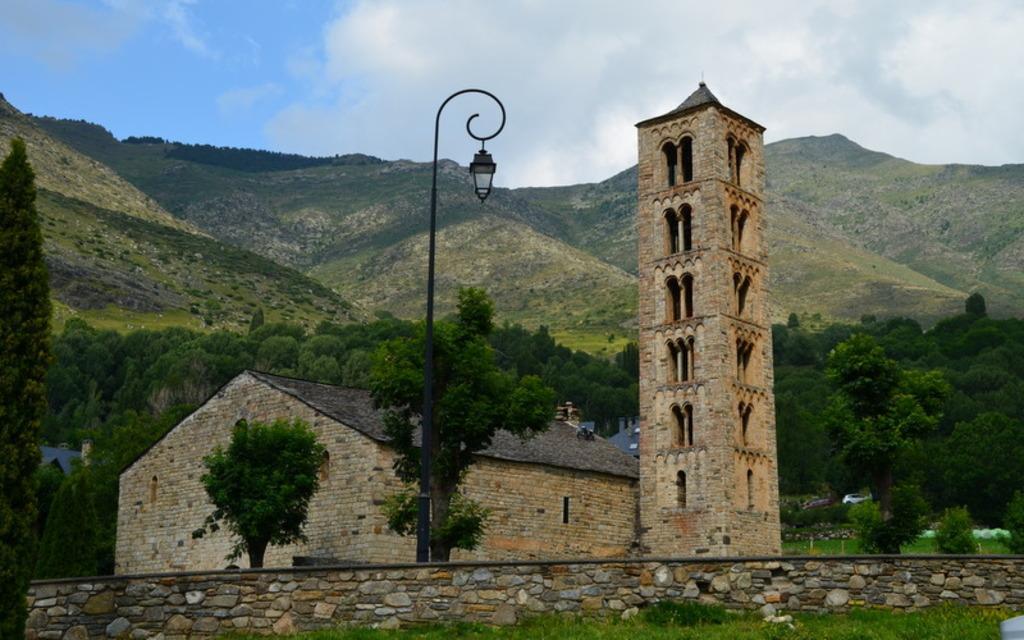Could you give a brief overview of what you see in this image? In the foreground of the image we can see a light pole , building with windows and a tower. In the background, we can see group of buildings , vehicle parked on ground , group of trees , mountains and the sky. 